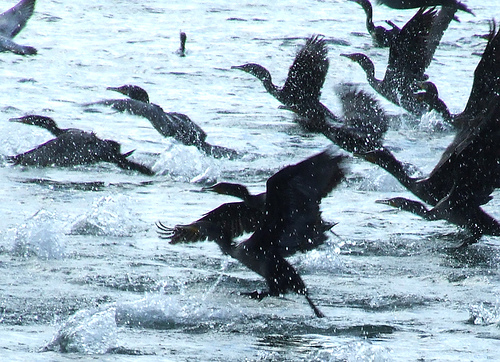Please provide the bounding box coordinate of the region this sentence describes: head of black bird in water. The bounding box coordinates for the region describing the 'head of black bird in water' are [0.35, 0.19, 0.39, 0.26]. It highlights the specific part of the image where the bird's head is seen within the water. 